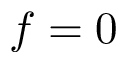<formula> <loc_0><loc_0><loc_500><loc_500>f = 0</formula> 